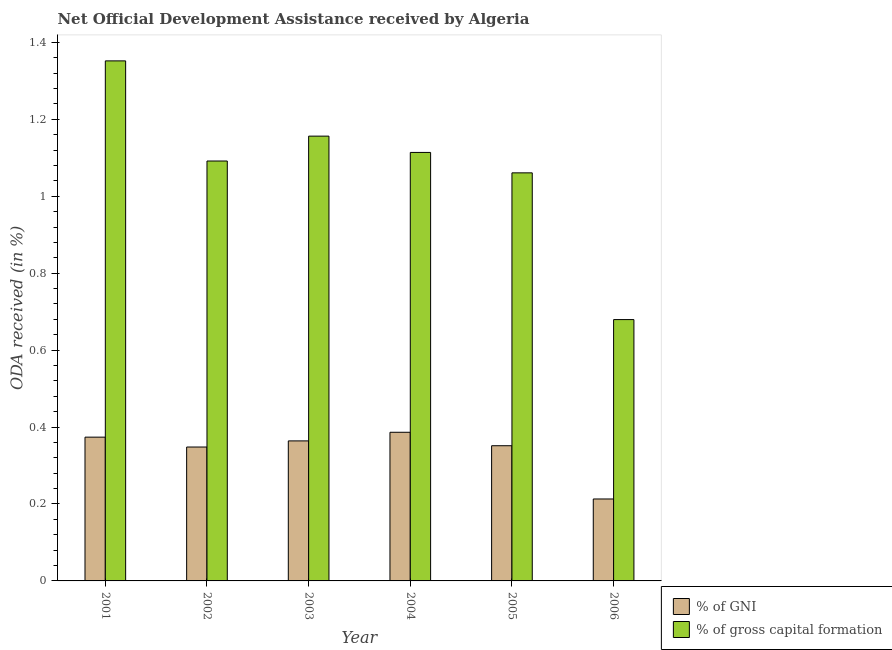How many different coloured bars are there?
Your answer should be compact. 2. Are the number of bars per tick equal to the number of legend labels?
Your answer should be very brief. Yes. How many bars are there on the 3rd tick from the left?
Keep it short and to the point. 2. How many bars are there on the 3rd tick from the right?
Provide a short and direct response. 2. What is the label of the 1st group of bars from the left?
Your answer should be very brief. 2001. What is the oda received as percentage of gni in 2006?
Give a very brief answer. 0.21. Across all years, what is the maximum oda received as percentage of gni?
Provide a short and direct response. 0.39. Across all years, what is the minimum oda received as percentage of gross capital formation?
Your response must be concise. 0.68. In which year was the oda received as percentage of gross capital formation maximum?
Give a very brief answer. 2001. What is the total oda received as percentage of gross capital formation in the graph?
Your answer should be compact. 6.45. What is the difference between the oda received as percentage of gross capital formation in 2004 and that in 2006?
Offer a very short reply. 0.43. What is the difference between the oda received as percentage of gni in 2001 and the oda received as percentage of gross capital formation in 2006?
Your answer should be very brief. 0.16. What is the average oda received as percentage of gni per year?
Offer a terse response. 0.34. What is the ratio of the oda received as percentage of gross capital formation in 2001 to that in 2004?
Your answer should be compact. 1.21. Is the oda received as percentage of gross capital formation in 2001 less than that in 2006?
Offer a terse response. No. What is the difference between the highest and the second highest oda received as percentage of gross capital formation?
Provide a short and direct response. 0.2. What is the difference between the highest and the lowest oda received as percentage of gni?
Your answer should be compact. 0.17. In how many years, is the oda received as percentage of gross capital formation greater than the average oda received as percentage of gross capital formation taken over all years?
Offer a terse response. 4. Is the sum of the oda received as percentage of gni in 2002 and 2004 greater than the maximum oda received as percentage of gross capital formation across all years?
Make the answer very short. Yes. What does the 2nd bar from the left in 2006 represents?
Keep it short and to the point. % of gross capital formation. What does the 2nd bar from the right in 2003 represents?
Ensure brevity in your answer.  % of GNI. Are all the bars in the graph horizontal?
Give a very brief answer. No. What is the difference between two consecutive major ticks on the Y-axis?
Give a very brief answer. 0.2. How many legend labels are there?
Offer a terse response. 2. What is the title of the graph?
Make the answer very short. Net Official Development Assistance received by Algeria. Does "Central government" appear as one of the legend labels in the graph?
Your answer should be compact. No. What is the label or title of the X-axis?
Provide a succinct answer. Year. What is the label or title of the Y-axis?
Keep it short and to the point. ODA received (in %). What is the ODA received (in %) in % of GNI in 2001?
Make the answer very short. 0.37. What is the ODA received (in %) in % of gross capital formation in 2001?
Your answer should be compact. 1.35. What is the ODA received (in %) of % of GNI in 2002?
Provide a succinct answer. 0.35. What is the ODA received (in %) of % of gross capital formation in 2002?
Offer a very short reply. 1.09. What is the ODA received (in %) of % of GNI in 2003?
Ensure brevity in your answer.  0.36. What is the ODA received (in %) of % of gross capital formation in 2003?
Offer a very short reply. 1.16. What is the ODA received (in %) in % of GNI in 2004?
Your response must be concise. 0.39. What is the ODA received (in %) in % of gross capital formation in 2004?
Keep it short and to the point. 1.11. What is the ODA received (in %) in % of GNI in 2005?
Offer a very short reply. 0.35. What is the ODA received (in %) of % of gross capital formation in 2005?
Make the answer very short. 1.06. What is the ODA received (in %) of % of GNI in 2006?
Provide a succinct answer. 0.21. What is the ODA received (in %) in % of gross capital formation in 2006?
Provide a succinct answer. 0.68. Across all years, what is the maximum ODA received (in %) of % of GNI?
Offer a very short reply. 0.39. Across all years, what is the maximum ODA received (in %) of % of gross capital formation?
Your answer should be compact. 1.35. Across all years, what is the minimum ODA received (in %) of % of GNI?
Offer a very short reply. 0.21. Across all years, what is the minimum ODA received (in %) of % of gross capital formation?
Provide a short and direct response. 0.68. What is the total ODA received (in %) in % of GNI in the graph?
Provide a short and direct response. 2.04. What is the total ODA received (in %) in % of gross capital formation in the graph?
Provide a short and direct response. 6.45. What is the difference between the ODA received (in %) in % of GNI in 2001 and that in 2002?
Your answer should be compact. 0.03. What is the difference between the ODA received (in %) of % of gross capital formation in 2001 and that in 2002?
Offer a very short reply. 0.26. What is the difference between the ODA received (in %) in % of GNI in 2001 and that in 2003?
Give a very brief answer. 0.01. What is the difference between the ODA received (in %) of % of gross capital formation in 2001 and that in 2003?
Make the answer very short. 0.2. What is the difference between the ODA received (in %) in % of GNI in 2001 and that in 2004?
Make the answer very short. -0.01. What is the difference between the ODA received (in %) in % of gross capital formation in 2001 and that in 2004?
Provide a short and direct response. 0.24. What is the difference between the ODA received (in %) of % of GNI in 2001 and that in 2005?
Offer a very short reply. 0.02. What is the difference between the ODA received (in %) in % of gross capital formation in 2001 and that in 2005?
Provide a succinct answer. 0.29. What is the difference between the ODA received (in %) of % of GNI in 2001 and that in 2006?
Your answer should be very brief. 0.16. What is the difference between the ODA received (in %) of % of gross capital formation in 2001 and that in 2006?
Your answer should be compact. 0.67. What is the difference between the ODA received (in %) in % of GNI in 2002 and that in 2003?
Offer a terse response. -0.02. What is the difference between the ODA received (in %) of % of gross capital formation in 2002 and that in 2003?
Keep it short and to the point. -0.06. What is the difference between the ODA received (in %) of % of GNI in 2002 and that in 2004?
Your answer should be very brief. -0.04. What is the difference between the ODA received (in %) in % of gross capital formation in 2002 and that in 2004?
Your response must be concise. -0.02. What is the difference between the ODA received (in %) in % of GNI in 2002 and that in 2005?
Provide a short and direct response. -0. What is the difference between the ODA received (in %) in % of gross capital formation in 2002 and that in 2005?
Offer a very short reply. 0.03. What is the difference between the ODA received (in %) of % of GNI in 2002 and that in 2006?
Your response must be concise. 0.14. What is the difference between the ODA received (in %) of % of gross capital formation in 2002 and that in 2006?
Offer a very short reply. 0.41. What is the difference between the ODA received (in %) of % of GNI in 2003 and that in 2004?
Provide a succinct answer. -0.02. What is the difference between the ODA received (in %) of % of gross capital formation in 2003 and that in 2004?
Your response must be concise. 0.04. What is the difference between the ODA received (in %) of % of GNI in 2003 and that in 2005?
Give a very brief answer. 0.01. What is the difference between the ODA received (in %) in % of gross capital formation in 2003 and that in 2005?
Give a very brief answer. 0.1. What is the difference between the ODA received (in %) of % of GNI in 2003 and that in 2006?
Make the answer very short. 0.15. What is the difference between the ODA received (in %) of % of gross capital formation in 2003 and that in 2006?
Offer a very short reply. 0.48. What is the difference between the ODA received (in %) in % of GNI in 2004 and that in 2005?
Offer a terse response. 0.04. What is the difference between the ODA received (in %) of % of gross capital formation in 2004 and that in 2005?
Offer a terse response. 0.05. What is the difference between the ODA received (in %) of % of GNI in 2004 and that in 2006?
Your answer should be very brief. 0.17. What is the difference between the ODA received (in %) of % of gross capital formation in 2004 and that in 2006?
Offer a very short reply. 0.43. What is the difference between the ODA received (in %) of % of GNI in 2005 and that in 2006?
Make the answer very short. 0.14. What is the difference between the ODA received (in %) in % of gross capital formation in 2005 and that in 2006?
Your response must be concise. 0.38. What is the difference between the ODA received (in %) in % of GNI in 2001 and the ODA received (in %) in % of gross capital formation in 2002?
Offer a very short reply. -0.72. What is the difference between the ODA received (in %) in % of GNI in 2001 and the ODA received (in %) in % of gross capital formation in 2003?
Your response must be concise. -0.78. What is the difference between the ODA received (in %) in % of GNI in 2001 and the ODA received (in %) in % of gross capital formation in 2004?
Keep it short and to the point. -0.74. What is the difference between the ODA received (in %) in % of GNI in 2001 and the ODA received (in %) in % of gross capital formation in 2005?
Offer a terse response. -0.69. What is the difference between the ODA received (in %) in % of GNI in 2001 and the ODA received (in %) in % of gross capital formation in 2006?
Your answer should be very brief. -0.31. What is the difference between the ODA received (in %) of % of GNI in 2002 and the ODA received (in %) of % of gross capital formation in 2003?
Provide a succinct answer. -0.81. What is the difference between the ODA received (in %) in % of GNI in 2002 and the ODA received (in %) in % of gross capital formation in 2004?
Keep it short and to the point. -0.77. What is the difference between the ODA received (in %) of % of GNI in 2002 and the ODA received (in %) of % of gross capital formation in 2005?
Provide a succinct answer. -0.71. What is the difference between the ODA received (in %) of % of GNI in 2002 and the ODA received (in %) of % of gross capital formation in 2006?
Your response must be concise. -0.33. What is the difference between the ODA received (in %) in % of GNI in 2003 and the ODA received (in %) in % of gross capital formation in 2004?
Provide a succinct answer. -0.75. What is the difference between the ODA received (in %) in % of GNI in 2003 and the ODA received (in %) in % of gross capital formation in 2005?
Ensure brevity in your answer.  -0.7. What is the difference between the ODA received (in %) in % of GNI in 2003 and the ODA received (in %) in % of gross capital formation in 2006?
Make the answer very short. -0.32. What is the difference between the ODA received (in %) in % of GNI in 2004 and the ODA received (in %) in % of gross capital formation in 2005?
Provide a succinct answer. -0.67. What is the difference between the ODA received (in %) of % of GNI in 2004 and the ODA received (in %) of % of gross capital formation in 2006?
Ensure brevity in your answer.  -0.29. What is the difference between the ODA received (in %) of % of GNI in 2005 and the ODA received (in %) of % of gross capital formation in 2006?
Provide a succinct answer. -0.33. What is the average ODA received (in %) in % of GNI per year?
Your answer should be compact. 0.34. What is the average ODA received (in %) of % of gross capital formation per year?
Make the answer very short. 1.08. In the year 2001, what is the difference between the ODA received (in %) of % of GNI and ODA received (in %) of % of gross capital formation?
Make the answer very short. -0.98. In the year 2002, what is the difference between the ODA received (in %) of % of GNI and ODA received (in %) of % of gross capital formation?
Give a very brief answer. -0.74. In the year 2003, what is the difference between the ODA received (in %) of % of GNI and ODA received (in %) of % of gross capital formation?
Provide a short and direct response. -0.79. In the year 2004, what is the difference between the ODA received (in %) in % of GNI and ODA received (in %) in % of gross capital formation?
Offer a very short reply. -0.73. In the year 2005, what is the difference between the ODA received (in %) in % of GNI and ODA received (in %) in % of gross capital formation?
Keep it short and to the point. -0.71. In the year 2006, what is the difference between the ODA received (in %) in % of GNI and ODA received (in %) in % of gross capital formation?
Keep it short and to the point. -0.47. What is the ratio of the ODA received (in %) in % of GNI in 2001 to that in 2002?
Keep it short and to the point. 1.07. What is the ratio of the ODA received (in %) of % of gross capital formation in 2001 to that in 2002?
Keep it short and to the point. 1.24. What is the ratio of the ODA received (in %) of % of GNI in 2001 to that in 2003?
Give a very brief answer. 1.03. What is the ratio of the ODA received (in %) of % of gross capital formation in 2001 to that in 2003?
Your answer should be compact. 1.17. What is the ratio of the ODA received (in %) in % of GNI in 2001 to that in 2004?
Keep it short and to the point. 0.97. What is the ratio of the ODA received (in %) of % of gross capital formation in 2001 to that in 2004?
Offer a very short reply. 1.21. What is the ratio of the ODA received (in %) of % of GNI in 2001 to that in 2005?
Offer a very short reply. 1.06. What is the ratio of the ODA received (in %) in % of gross capital formation in 2001 to that in 2005?
Give a very brief answer. 1.27. What is the ratio of the ODA received (in %) of % of GNI in 2001 to that in 2006?
Your answer should be very brief. 1.75. What is the ratio of the ODA received (in %) in % of gross capital formation in 2001 to that in 2006?
Your answer should be very brief. 1.99. What is the ratio of the ODA received (in %) in % of GNI in 2002 to that in 2003?
Your answer should be very brief. 0.96. What is the ratio of the ODA received (in %) in % of gross capital formation in 2002 to that in 2003?
Give a very brief answer. 0.94. What is the ratio of the ODA received (in %) in % of GNI in 2002 to that in 2004?
Offer a terse response. 0.9. What is the ratio of the ODA received (in %) in % of gross capital formation in 2002 to that in 2004?
Offer a very short reply. 0.98. What is the ratio of the ODA received (in %) in % of GNI in 2002 to that in 2005?
Your answer should be very brief. 0.99. What is the ratio of the ODA received (in %) of % of gross capital formation in 2002 to that in 2005?
Provide a short and direct response. 1.03. What is the ratio of the ODA received (in %) of % of GNI in 2002 to that in 2006?
Provide a succinct answer. 1.63. What is the ratio of the ODA received (in %) in % of gross capital formation in 2002 to that in 2006?
Offer a very short reply. 1.61. What is the ratio of the ODA received (in %) of % of GNI in 2003 to that in 2004?
Give a very brief answer. 0.94. What is the ratio of the ODA received (in %) in % of gross capital formation in 2003 to that in 2004?
Your answer should be compact. 1.04. What is the ratio of the ODA received (in %) in % of GNI in 2003 to that in 2005?
Provide a succinct answer. 1.04. What is the ratio of the ODA received (in %) of % of gross capital formation in 2003 to that in 2005?
Provide a succinct answer. 1.09. What is the ratio of the ODA received (in %) in % of GNI in 2003 to that in 2006?
Make the answer very short. 1.71. What is the ratio of the ODA received (in %) in % of gross capital formation in 2003 to that in 2006?
Keep it short and to the point. 1.7. What is the ratio of the ODA received (in %) in % of GNI in 2004 to that in 2005?
Ensure brevity in your answer.  1.1. What is the ratio of the ODA received (in %) in % of gross capital formation in 2004 to that in 2005?
Keep it short and to the point. 1.05. What is the ratio of the ODA received (in %) in % of GNI in 2004 to that in 2006?
Your answer should be compact. 1.81. What is the ratio of the ODA received (in %) of % of gross capital formation in 2004 to that in 2006?
Your answer should be compact. 1.64. What is the ratio of the ODA received (in %) of % of GNI in 2005 to that in 2006?
Provide a succinct answer. 1.65. What is the ratio of the ODA received (in %) of % of gross capital formation in 2005 to that in 2006?
Your answer should be very brief. 1.56. What is the difference between the highest and the second highest ODA received (in %) in % of GNI?
Offer a very short reply. 0.01. What is the difference between the highest and the second highest ODA received (in %) in % of gross capital formation?
Make the answer very short. 0.2. What is the difference between the highest and the lowest ODA received (in %) of % of GNI?
Ensure brevity in your answer.  0.17. What is the difference between the highest and the lowest ODA received (in %) in % of gross capital formation?
Offer a very short reply. 0.67. 